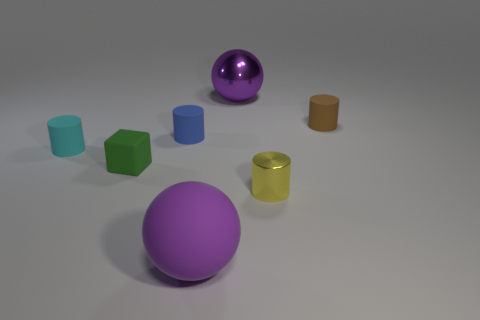Subtract all purple cylinders. Subtract all yellow cubes. How many cylinders are left? 4 Add 1 tiny green spheres. How many objects exist? 8 Subtract all cylinders. How many objects are left? 3 Subtract 0 yellow blocks. How many objects are left? 7 Subtract all tiny green blocks. Subtract all brown metallic cubes. How many objects are left? 6 Add 1 shiny cylinders. How many shiny cylinders are left? 2 Add 5 small cyan objects. How many small cyan objects exist? 6 